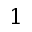Convert formula to latex. <formula><loc_0><loc_0><loc_500><loc_500>1</formula> 